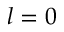Convert formula to latex. <formula><loc_0><loc_0><loc_500><loc_500>l = 0</formula> 